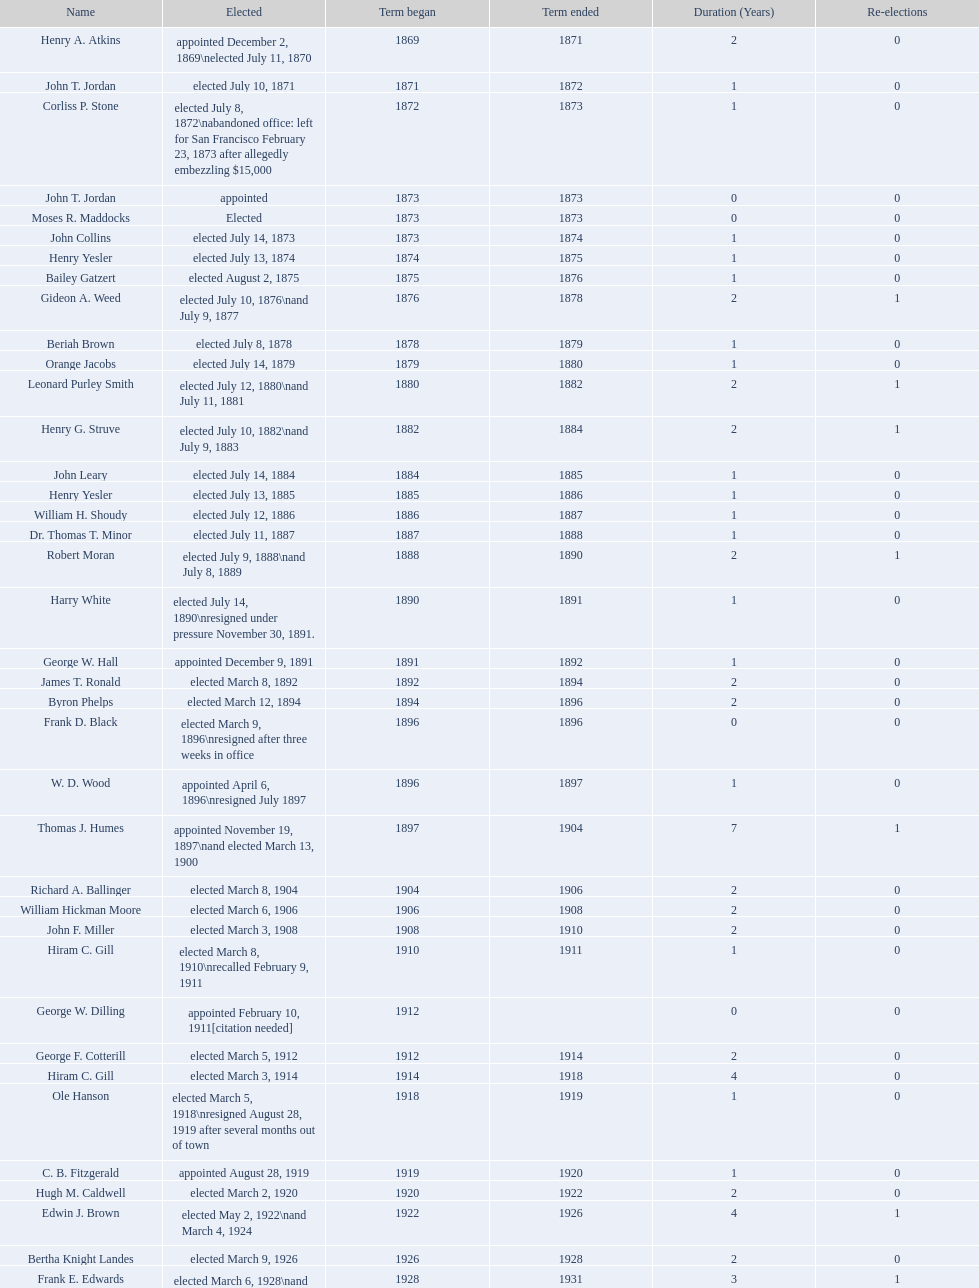What is the number of mayors with the first name of john? 6. 